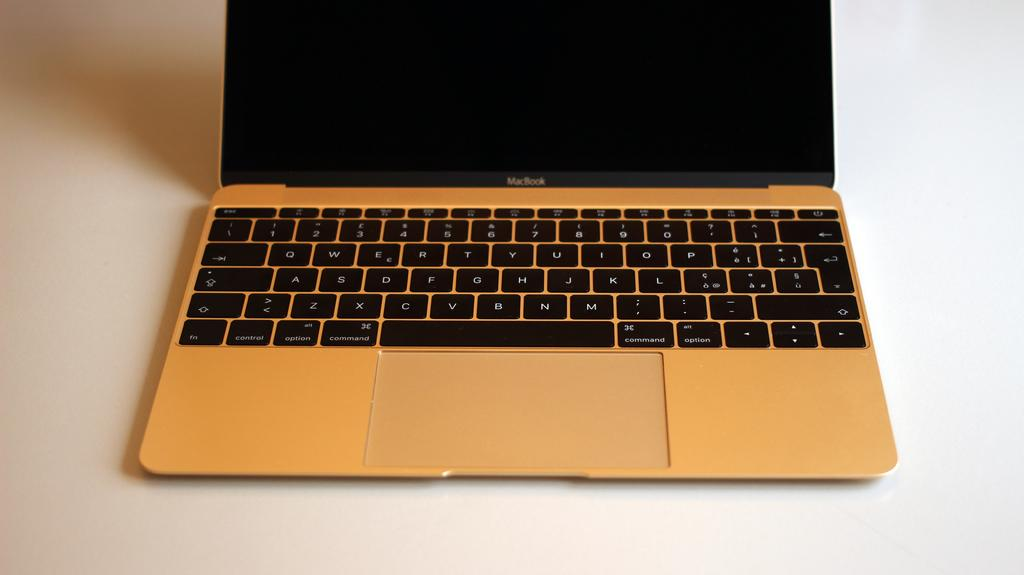<image>
Relay a brief, clear account of the picture shown. An open Mac Book sits on a white surface. 